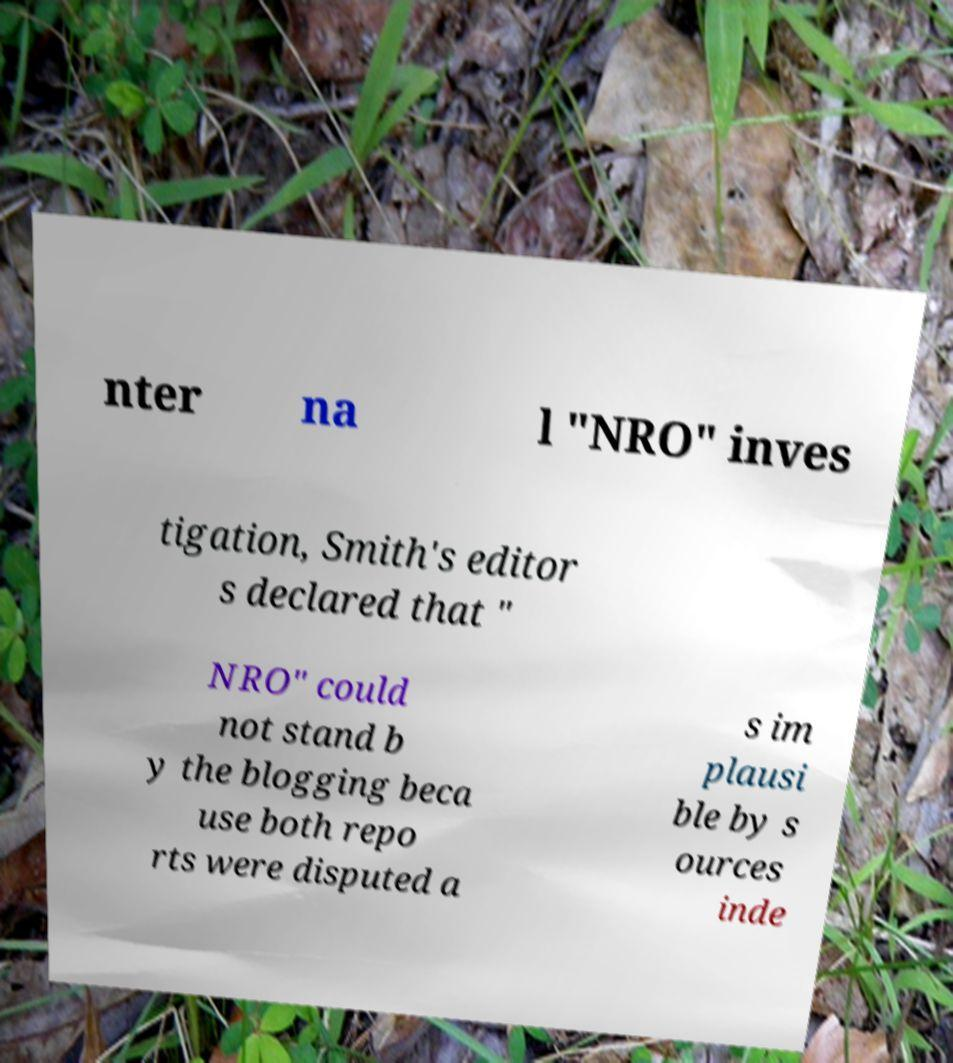There's text embedded in this image that I need extracted. Can you transcribe it verbatim? nter na l "NRO" inves tigation, Smith's editor s declared that " NRO" could not stand b y the blogging beca use both repo rts were disputed a s im plausi ble by s ources inde 